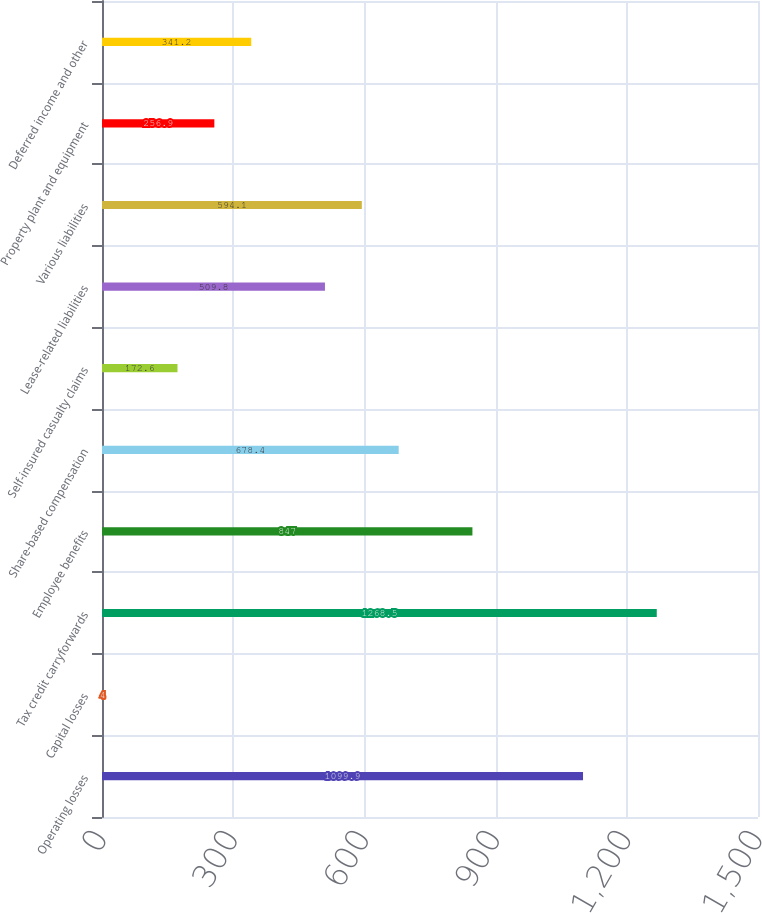Convert chart to OTSL. <chart><loc_0><loc_0><loc_500><loc_500><bar_chart><fcel>Operating losses<fcel>Capital losses<fcel>Tax credit carryforwards<fcel>Employee benefits<fcel>Share-based compensation<fcel>Self-insured casualty claims<fcel>Lease-related liabilities<fcel>Various liabilities<fcel>Property plant and equipment<fcel>Deferred income and other<nl><fcel>1099.9<fcel>4<fcel>1268.5<fcel>847<fcel>678.4<fcel>172.6<fcel>509.8<fcel>594.1<fcel>256.9<fcel>341.2<nl></chart> 